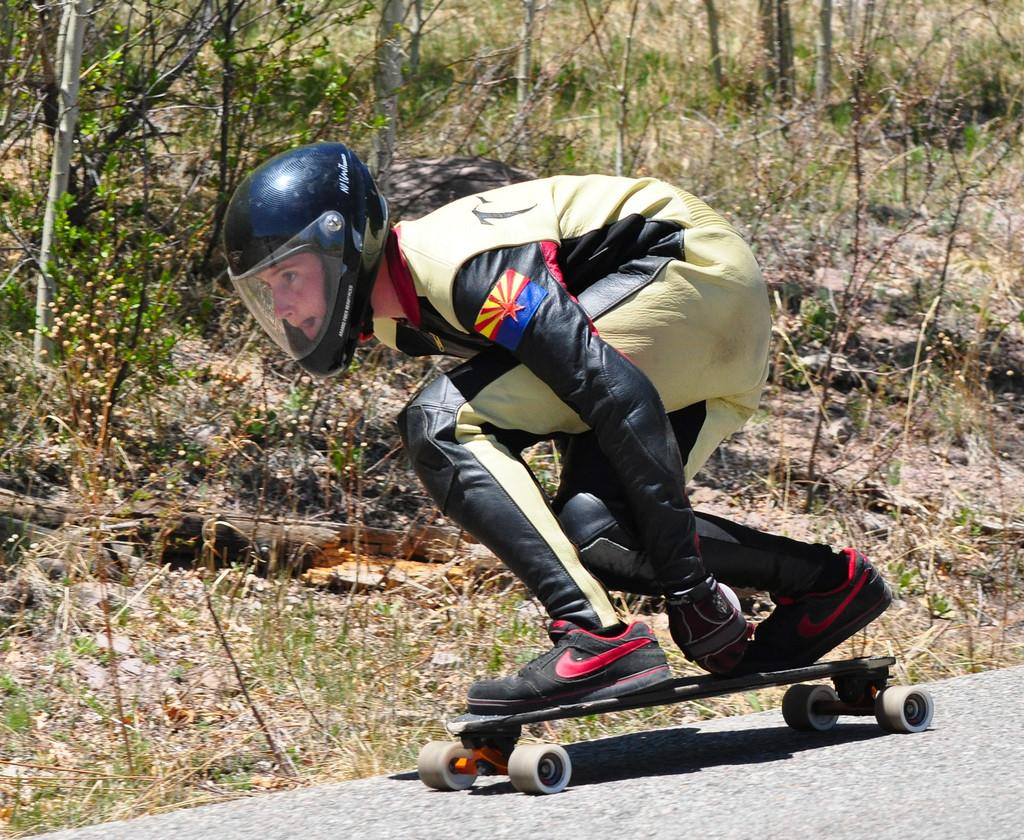Who is the main subject in the image? There is a woman in the image. What is the woman wearing? The woman is wearing a sports dress and helmet. What activity is the woman engaged in? The woman is skating with a skateboard. Where is the woman skating? The woman is on a road. What can be seen in the background of the image? There are trees and plants visible in the background. What type of poisonous attraction can be seen in the image? There is no poisonous attraction present in the image. 